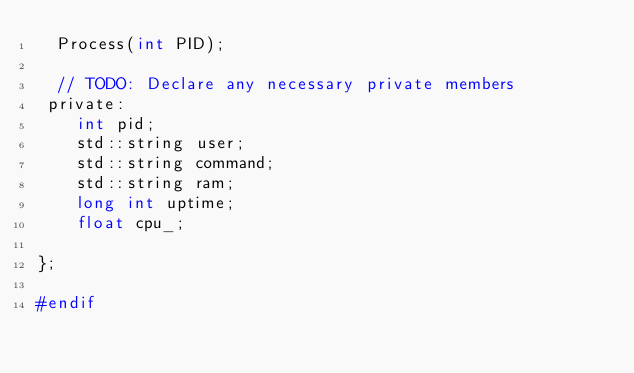Convert code to text. <code><loc_0><loc_0><loc_500><loc_500><_C_>  Process(int PID);

  // TODO: Declare any necessary private members
 private:
    int pid;
    std::string user;
    std::string command;
    std::string ram;
    long int uptime;
    float cpu_;
    
};

#endif</code> 